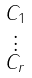Convert formula to latex. <formula><loc_0><loc_0><loc_500><loc_500>\begin{smallmatrix} C _ { 1 } \\ \vdots \\ C _ { r } \end{smallmatrix}</formula> 